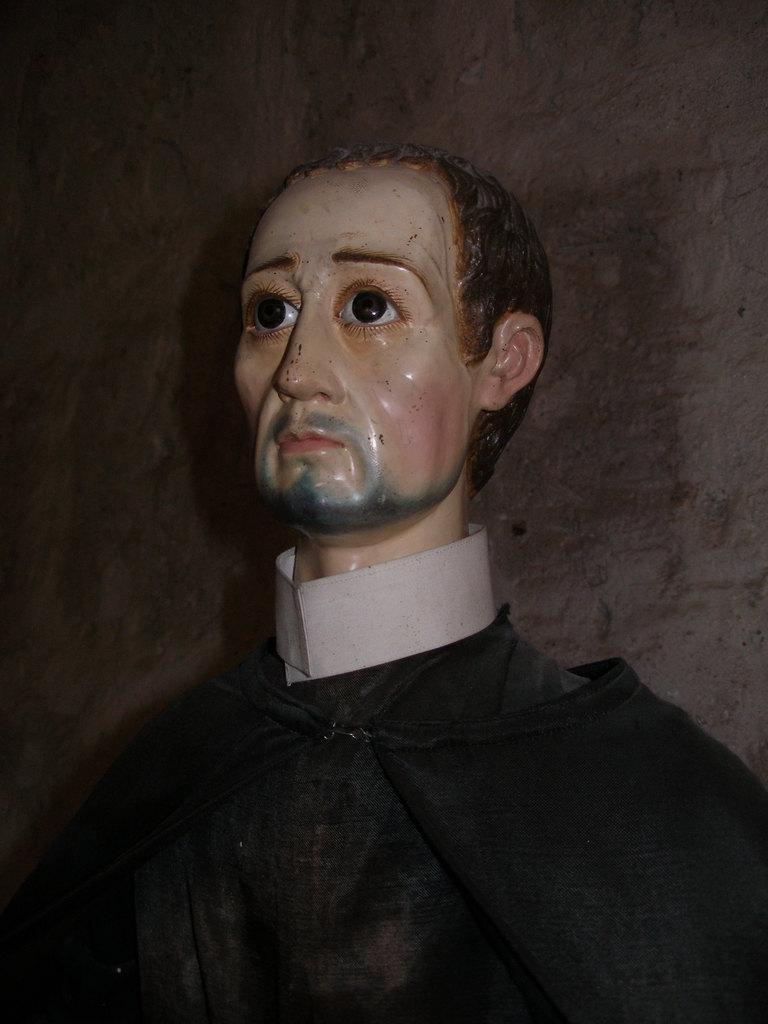What is the main subject in the image? There is a mannequin in the image. What color is the background of the image? The background of the image is in gray color. What type of comb is the mannequin using in the image? There is no comb present in the image; it only features a mannequin and a gray background. 